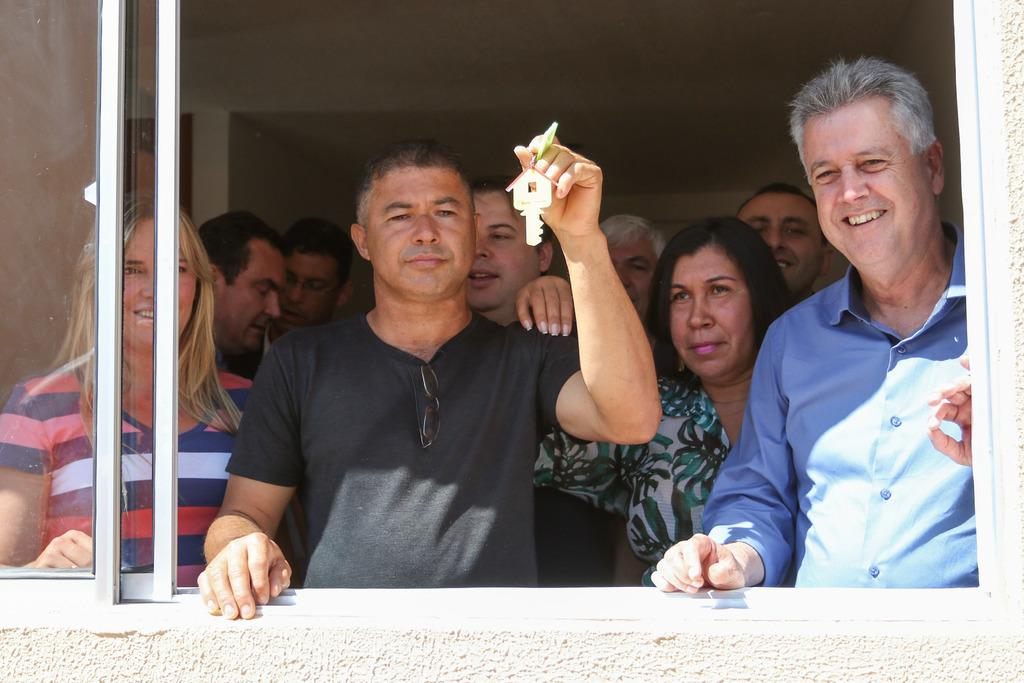How many people are in the image? There are many people in the image. What is one man doing in the image? One man is catching a key. What type of material is used for the windows in the image? There are glass windows present in the image. What type of comfort is provided by the slave in the image? There is no mention of a slave or any comfort being provided in the image. 